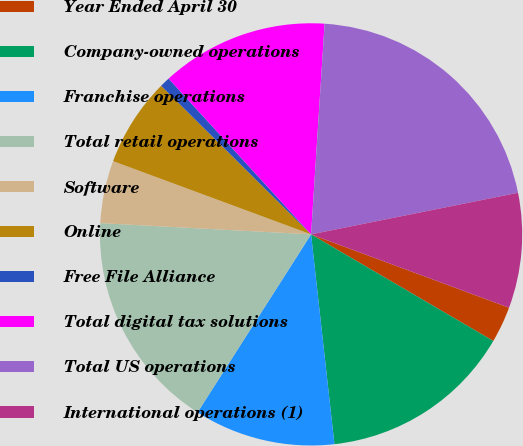<chart> <loc_0><loc_0><loc_500><loc_500><pie_chart><fcel>Year Ended April 30<fcel>Company-owned operations<fcel>Franchise operations<fcel>Total retail operations<fcel>Software<fcel>Online<fcel>Free File Alliance<fcel>Total digital tax solutions<fcel>Total US operations<fcel>International operations (1)<nl><fcel>2.78%<fcel>14.81%<fcel>10.8%<fcel>16.81%<fcel>4.79%<fcel>6.79%<fcel>0.78%<fcel>12.81%<fcel>20.82%<fcel>8.8%<nl></chart> 